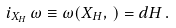<formula> <loc_0><loc_0><loc_500><loc_500>i _ { X _ { H } } \, \omega \equiv \omega ( X _ { H } , \, ) = d H \, .</formula> 